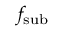<formula> <loc_0><loc_0><loc_500><loc_500>f _ { s u b }</formula> 